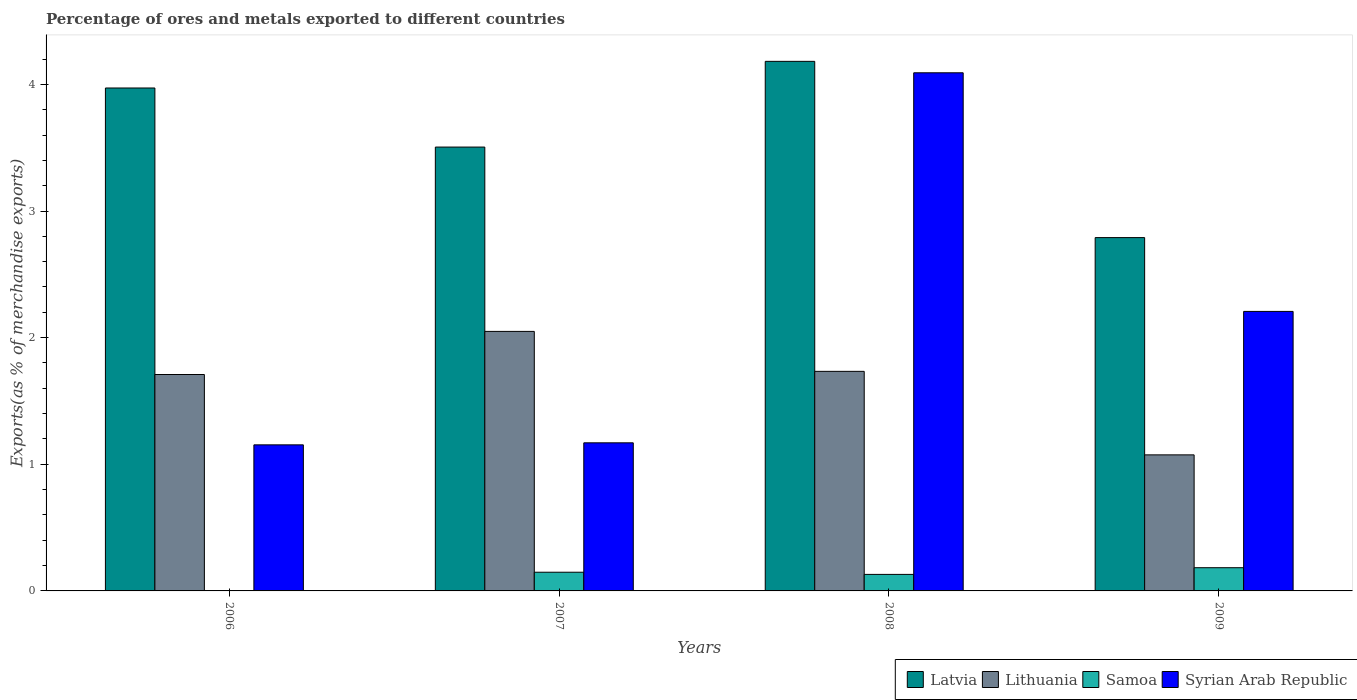How many groups of bars are there?
Your response must be concise. 4. Are the number of bars on each tick of the X-axis equal?
Your response must be concise. Yes. How many bars are there on the 1st tick from the right?
Your answer should be compact. 4. What is the label of the 4th group of bars from the left?
Provide a succinct answer. 2009. What is the percentage of exports to different countries in Samoa in 2009?
Give a very brief answer. 0.18. Across all years, what is the maximum percentage of exports to different countries in Latvia?
Provide a short and direct response. 4.18. Across all years, what is the minimum percentage of exports to different countries in Lithuania?
Provide a short and direct response. 1.07. In which year was the percentage of exports to different countries in Samoa maximum?
Keep it short and to the point. 2009. In which year was the percentage of exports to different countries in Latvia minimum?
Provide a succinct answer. 2009. What is the total percentage of exports to different countries in Syrian Arab Republic in the graph?
Provide a short and direct response. 8.62. What is the difference between the percentage of exports to different countries in Samoa in 2008 and that in 2009?
Provide a short and direct response. -0.05. What is the difference between the percentage of exports to different countries in Latvia in 2007 and the percentage of exports to different countries in Syrian Arab Republic in 2009?
Offer a terse response. 1.3. What is the average percentage of exports to different countries in Lithuania per year?
Keep it short and to the point. 1.64. In the year 2006, what is the difference between the percentage of exports to different countries in Samoa and percentage of exports to different countries in Lithuania?
Your answer should be very brief. -1.71. In how many years, is the percentage of exports to different countries in Samoa greater than 3.4 %?
Offer a terse response. 0. What is the ratio of the percentage of exports to different countries in Lithuania in 2006 to that in 2009?
Your answer should be compact. 1.59. Is the percentage of exports to different countries in Syrian Arab Republic in 2007 less than that in 2008?
Ensure brevity in your answer.  Yes. What is the difference between the highest and the second highest percentage of exports to different countries in Syrian Arab Republic?
Keep it short and to the point. 1.88. What is the difference between the highest and the lowest percentage of exports to different countries in Latvia?
Keep it short and to the point. 1.39. In how many years, is the percentage of exports to different countries in Syrian Arab Republic greater than the average percentage of exports to different countries in Syrian Arab Republic taken over all years?
Offer a very short reply. 2. Is the sum of the percentage of exports to different countries in Samoa in 2007 and 2009 greater than the maximum percentage of exports to different countries in Syrian Arab Republic across all years?
Provide a succinct answer. No. What does the 3rd bar from the left in 2007 represents?
Keep it short and to the point. Samoa. What does the 4th bar from the right in 2007 represents?
Offer a very short reply. Latvia. Are all the bars in the graph horizontal?
Keep it short and to the point. No. How many years are there in the graph?
Make the answer very short. 4. Are the values on the major ticks of Y-axis written in scientific E-notation?
Provide a succinct answer. No. Does the graph contain any zero values?
Give a very brief answer. No. What is the title of the graph?
Make the answer very short. Percentage of ores and metals exported to different countries. Does "Barbados" appear as one of the legend labels in the graph?
Your response must be concise. No. What is the label or title of the X-axis?
Give a very brief answer. Years. What is the label or title of the Y-axis?
Ensure brevity in your answer.  Exports(as % of merchandise exports). What is the Exports(as % of merchandise exports) of Latvia in 2006?
Ensure brevity in your answer.  3.97. What is the Exports(as % of merchandise exports) in Lithuania in 2006?
Offer a very short reply. 1.71. What is the Exports(as % of merchandise exports) in Samoa in 2006?
Keep it short and to the point. 0. What is the Exports(as % of merchandise exports) of Syrian Arab Republic in 2006?
Your response must be concise. 1.15. What is the Exports(as % of merchandise exports) in Latvia in 2007?
Give a very brief answer. 3.5. What is the Exports(as % of merchandise exports) of Lithuania in 2007?
Your response must be concise. 2.05. What is the Exports(as % of merchandise exports) of Samoa in 2007?
Make the answer very short. 0.15. What is the Exports(as % of merchandise exports) of Syrian Arab Republic in 2007?
Offer a terse response. 1.17. What is the Exports(as % of merchandise exports) in Latvia in 2008?
Offer a terse response. 4.18. What is the Exports(as % of merchandise exports) in Lithuania in 2008?
Ensure brevity in your answer.  1.73. What is the Exports(as % of merchandise exports) in Samoa in 2008?
Provide a succinct answer. 0.13. What is the Exports(as % of merchandise exports) in Syrian Arab Republic in 2008?
Offer a terse response. 4.09. What is the Exports(as % of merchandise exports) of Latvia in 2009?
Offer a very short reply. 2.79. What is the Exports(as % of merchandise exports) in Lithuania in 2009?
Provide a succinct answer. 1.07. What is the Exports(as % of merchandise exports) in Samoa in 2009?
Your answer should be compact. 0.18. What is the Exports(as % of merchandise exports) of Syrian Arab Republic in 2009?
Provide a succinct answer. 2.21. Across all years, what is the maximum Exports(as % of merchandise exports) in Latvia?
Provide a short and direct response. 4.18. Across all years, what is the maximum Exports(as % of merchandise exports) in Lithuania?
Offer a terse response. 2.05. Across all years, what is the maximum Exports(as % of merchandise exports) of Samoa?
Ensure brevity in your answer.  0.18. Across all years, what is the maximum Exports(as % of merchandise exports) of Syrian Arab Republic?
Give a very brief answer. 4.09. Across all years, what is the minimum Exports(as % of merchandise exports) of Latvia?
Give a very brief answer. 2.79. Across all years, what is the minimum Exports(as % of merchandise exports) in Lithuania?
Your response must be concise. 1.07. Across all years, what is the minimum Exports(as % of merchandise exports) in Samoa?
Offer a very short reply. 0. Across all years, what is the minimum Exports(as % of merchandise exports) in Syrian Arab Republic?
Make the answer very short. 1.15. What is the total Exports(as % of merchandise exports) of Latvia in the graph?
Provide a short and direct response. 14.45. What is the total Exports(as % of merchandise exports) of Lithuania in the graph?
Make the answer very short. 6.57. What is the total Exports(as % of merchandise exports) of Samoa in the graph?
Your answer should be very brief. 0.46. What is the total Exports(as % of merchandise exports) of Syrian Arab Republic in the graph?
Provide a succinct answer. 8.62. What is the difference between the Exports(as % of merchandise exports) of Latvia in 2006 and that in 2007?
Your answer should be very brief. 0.47. What is the difference between the Exports(as % of merchandise exports) in Lithuania in 2006 and that in 2007?
Offer a terse response. -0.34. What is the difference between the Exports(as % of merchandise exports) of Samoa in 2006 and that in 2007?
Keep it short and to the point. -0.15. What is the difference between the Exports(as % of merchandise exports) of Syrian Arab Republic in 2006 and that in 2007?
Keep it short and to the point. -0.02. What is the difference between the Exports(as % of merchandise exports) in Latvia in 2006 and that in 2008?
Provide a succinct answer. -0.21. What is the difference between the Exports(as % of merchandise exports) of Lithuania in 2006 and that in 2008?
Make the answer very short. -0.02. What is the difference between the Exports(as % of merchandise exports) in Samoa in 2006 and that in 2008?
Provide a short and direct response. -0.13. What is the difference between the Exports(as % of merchandise exports) of Syrian Arab Republic in 2006 and that in 2008?
Give a very brief answer. -2.94. What is the difference between the Exports(as % of merchandise exports) of Latvia in 2006 and that in 2009?
Your answer should be compact. 1.18. What is the difference between the Exports(as % of merchandise exports) of Lithuania in 2006 and that in 2009?
Provide a short and direct response. 0.63. What is the difference between the Exports(as % of merchandise exports) in Samoa in 2006 and that in 2009?
Make the answer very short. -0.18. What is the difference between the Exports(as % of merchandise exports) in Syrian Arab Republic in 2006 and that in 2009?
Ensure brevity in your answer.  -1.05. What is the difference between the Exports(as % of merchandise exports) in Latvia in 2007 and that in 2008?
Your answer should be very brief. -0.68. What is the difference between the Exports(as % of merchandise exports) in Lithuania in 2007 and that in 2008?
Give a very brief answer. 0.32. What is the difference between the Exports(as % of merchandise exports) in Samoa in 2007 and that in 2008?
Keep it short and to the point. 0.02. What is the difference between the Exports(as % of merchandise exports) of Syrian Arab Republic in 2007 and that in 2008?
Your response must be concise. -2.92. What is the difference between the Exports(as % of merchandise exports) of Latvia in 2007 and that in 2009?
Make the answer very short. 0.71. What is the difference between the Exports(as % of merchandise exports) of Lithuania in 2007 and that in 2009?
Offer a very short reply. 0.97. What is the difference between the Exports(as % of merchandise exports) of Samoa in 2007 and that in 2009?
Keep it short and to the point. -0.04. What is the difference between the Exports(as % of merchandise exports) of Syrian Arab Republic in 2007 and that in 2009?
Give a very brief answer. -1.04. What is the difference between the Exports(as % of merchandise exports) of Latvia in 2008 and that in 2009?
Your answer should be very brief. 1.39. What is the difference between the Exports(as % of merchandise exports) of Lithuania in 2008 and that in 2009?
Your response must be concise. 0.66. What is the difference between the Exports(as % of merchandise exports) of Samoa in 2008 and that in 2009?
Ensure brevity in your answer.  -0.05. What is the difference between the Exports(as % of merchandise exports) of Syrian Arab Republic in 2008 and that in 2009?
Ensure brevity in your answer.  1.88. What is the difference between the Exports(as % of merchandise exports) in Latvia in 2006 and the Exports(as % of merchandise exports) in Lithuania in 2007?
Your response must be concise. 1.92. What is the difference between the Exports(as % of merchandise exports) in Latvia in 2006 and the Exports(as % of merchandise exports) in Samoa in 2007?
Keep it short and to the point. 3.82. What is the difference between the Exports(as % of merchandise exports) of Latvia in 2006 and the Exports(as % of merchandise exports) of Syrian Arab Republic in 2007?
Provide a short and direct response. 2.8. What is the difference between the Exports(as % of merchandise exports) in Lithuania in 2006 and the Exports(as % of merchandise exports) in Samoa in 2007?
Make the answer very short. 1.56. What is the difference between the Exports(as % of merchandise exports) of Lithuania in 2006 and the Exports(as % of merchandise exports) of Syrian Arab Republic in 2007?
Make the answer very short. 0.54. What is the difference between the Exports(as % of merchandise exports) in Samoa in 2006 and the Exports(as % of merchandise exports) in Syrian Arab Republic in 2007?
Offer a terse response. -1.17. What is the difference between the Exports(as % of merchandise exports) of Latvia in 2006 and the Exports(as % of merchandise exports) of Lithuania in 2008?
Offer a terse response. 2.24. What is the difference between the Exports(as % of merchandise exports) in Latvia in 2006 and the Exports(as % of merchandise exports) in Samoa in 2008?
Keep it short and to the point. 3.84. What is the difference between the Exports(as % of merchandise exports) of Latvia in 2006 and the Exports(as % of merchandise exports) of Syrian Arab Republic in 2008?
Offer a very short reply. -0.12. What is the difference between the Exports(as % of merchandise exports) in Lithuania in 2006 and the Exports(as % of merchandise exports) in Samoa in 2008?
Your answer should be compact. 1.58. What is the difference between the Exports(as % of merchandise exports) in Lithuania in 2006 and the Exports(as % of merchandise exports) in Syrian Arab Republic in 2008?
Provide a succinct answer. -2.38. What is the difference between the Exports(as % of merchandise exports) in Samoa in 2006 and the Exports(as % of merchandise exports) in Syrian Arab Republic in 2008?
Provide a succinct answer. -4.09. What is the difference between the Exports(as % of merchandise exports) in Latvia in 2006 and the Exports(as % of merchandise exports) in Lithuania in 2009?
Your answer should be very brief. 2.9. What is the difference between the Exports(as % of merchandise exports) in Latvia in 2006 and the Exports(as % of merchandise exports) in Samoa in 2009?
Your answer should be compact. 3.79. What is the difference between the Exports(as % of merchandise exports) in Latvia in 2006 and the Exports(as % of merchandise exports) in Syrian Arab Republic in 2009?
Your response must be concise. 1.76. What is the difference between the Exports(as % of merchandise exports) in Lithuania in 2006 and the Exports(as % of merchandise exports) in Samoa in 2009?
Make the answer very short. 1.53. What is the difference between the Exports(as % of merchandise exports) in Lithuania in 2006 and the Exports(as % of merchandise exports) in Syrian Arab Republic in 2009?
Offer a terse response. -0.5. What is the difference between the Exports(as % of merchandise exports) in Samoa in 2006 and the Exports(as % of merchandise exports) in Syrian Arab Republic in 2009?
Make the answer very short. -2.21. What is the difference between the Exports(as % of merchandise exports) in Latvia in 2007 and the Exports(as % of merchandise exports) in Lithuania in 2008?
Make the answer very short. 1.77. What is the difference between the Exports(as % of merchandise exports) of Latvia in 2007 and the Exports(as % of merchandise exports) of Samoa in 2008?
Ensure brevity in your answer.  3.37. What is the difference between the Exports(as % of merchandise exports) of Latvia in 2007 and the Exports(as % of merchandise exports) of Syrian Arab Republic in 2008?
Offer a terse response. -0.59. What is the difference between the Exports(as % of merchandise exports) of Lithuania in 2007 and the Exports(as % of merchandise exports) of Samoa in 2008?
Offer a very short reply. 1.92. What is the difference between the Exports(as % of merchandise exports) in Lithuania in 2007 and the Exports(as % of merchandise exports) in Syrian Arab Republic in 2008?
Ensure brevity in your answer.  -2.04. What is the difference between the Exports(as % of merchandise exports) of Samoa in 2007 and the Exports(as % of merchandise exports) of Syrian Arab Republic in 2008?
Provide a succinct answer. -3.94. What is the difference between the Exports(as % of merchandise exports) of Latvia in 2007 and the Exports(as % of merchandise exports) of Lithuania in 2009?
Keep it short and to the point. 2.43. What is the difference between the Exports(as % of merchandise exports) in Latvia in 2007 and the Exports(as % of merchandise exports) in Samoa in 2009?
Your answer should be compact. 3.32. What is the difference between the Exports(as % of merchandise exports) of Latvia in 2007 and the Exports(as % of merchandise exports) of Syrian Arab Republic in 2009?
Provide a succinct answer. 1.3. What is the difference between the Exports(as % of merchandise exports) in Lithuania in 2007 and the Exports(as % of merchandise exports) in Samoa in 2009?
Give a very brief answer. 1.87. What is the difference between the Exports(as % of merchandise exports) of Lithuania in 2007 and the Exports(as % of merchandise exports) of Syrian Arab Republic in 2009?
Give a very brief answer. -0.16. What is the difference between the Exports(as % of merchandise exports) in Samoa in 2007 and the Exports(as % of merchandise exports) in Syrian Arab Republic in 2009?
Make the answer very short. -2.06. What is the difference between the Exports(as % of merchandise exports) in Latvia in 2008 and the Exports(as % of merchandise exports) in Lithuania in 2009?
Keep it short and to the point. 3.11. What is the difference between the Exports(as % of merchandise exports) of Latvia in 2008 and the Exports(as % of merchandise exports) of Samoa in 2009?
Make the answer very short. 4. What is the difference between the Exports(as % of merchandise exports) in Latvia in 2008 and the Exports(as % of merchandise exports) in Syrian Arab Republic in 2009?
Offer a terse response. 1.97. What is the difference between the Exports(as % of merchandise exports) of Lithuania in 2008 and the Exports(as % of merchandise exports) of Samoa in 2009?
Offer a terse response. 1.55. What is the difference between the Exports(as % of merchandise exports) in Lithuania in 2008 and the Exports(as % of merchandise exports) in Syrian Arab Republic in 2009?
Offer a very short reply. -0.47. What is the difference between the Exports(as % of merchandise exports) of Samoa in 2008 and the Exports(as % of merchandise exports) of Syrian Arab Republic in 2009?
Ensure brevity in your answer.  -2.08. What is the average Exports(as % of merchandise exports) in Latvia per year?
Offer a terse response. 3.61. What is the average Exports(as % of merchandise exports) of Lithuania per year?
Provide a succinct answer. 1.64. What is the average Exports(as % of merchandise exports) of Samoa per year?
Your answer should be compact. 0.12. What is the average Exports(as % of merchandise exports) of Syrian Arab Republic per year?
Offer a terse response. 2.16. In the year 2006, what is the difference between the Exports(as % of merchandise exports) of Latvia and Exports(as % of merchandise exports) of Lithuania?
Offer a terse response. 2.26. In the year 2006, what is the difference between the Exports(as % of merchandise exports) of Latvia and Exports(as % of merchandise exports) of Samoa?
Offer a terse response. 3.97. In the year 2006, what is the difference between the Exports(as % of merchandise exports) of Latvia and Exports(as % of merchandise exports) of Syrian Arab Republic?
Give a very brief answer. 2.82. In the year 2006, what is the difference between the Exports(as % of merchandise exports) of Lithuania and Exports(as % of merchandise exports) of Samoa?
Keep it short and to the point. 1.71. In the year 2006, what is the difference between the Exports(as % of merchandise exports) of Lithuania and Exports(as % of merchandise exports) of Syrian Arab Republic?
Give a very brief answer. 0.56. In the year 2006, what is the difference between the Exports(as % of merchandise exports) of Samoa and Exports(as % of merchandise exports) of Syrian Arab Republic?
Make the answer very short. -1.15. In the year 2007, what is the difference between the Exports(as % of merchandise exports) in Latvia and Exports(as % of merchandise exports) in Lithuania?
Your response must be concise. 1.46. In the year 2007, what is the difference between the Exports(as % of merchandise exports) of Latvia and Exports(as % of merchandise exports) of Samoa?
Provide a succinct answer. 3.36. In the year 2007, what is the difference between the Exports(as % of merchandise exports) in Latvia and Exports(as % of merchandise exports) in Syrian Arab Republic?
Ensure brevity in your answer.  2.34. In the year 2007, what is the difference between the Exports(as % of merchandise exports) of Lithuania and Exports(as % of merchandise exports) of Samoa?
Offer a very short reply. 1.9. In the year 2007, what is the difference between the Exports(as % of merchandise exports) of Lithuania and Exports(as % of merchandise exports) of Syrian Arab Republic?
Provide a succinct answer. 0.88. In the year 2007, what is the difference between the Exports(as % of merchandise exports) in Samoa and Exports(as % of merchandise exports) in Syrian Arab Republic?
Make the answer very short. -1.02. In the year 2008, what is the difference between the Exports(as % of merchandise exports) of Latvia and Exports(as % of merchandise exports) of Lithuania?
Your response must be concise. 2.45. In the year 2008, what is the difference between the Exports(as % of merchandise exports) of Latvia and Exports(as % of merchandise exports) of Samoa?
Provide a short and direct response. 4.05. In the year 2008, what is the difference between the Exports(as % of merchandise exports) in Latvia and Exports(as % of merchandise exports) in Syrian Arab Republic?
Your answer should be compact. 0.09. In the year 2008, what is the difference between the Exports(as % of merchandise exports) of Lithuania and Exports(as % of merchandise exports) of Samoa?
Give a very brief answer. 1.6. In the year 2008, what is the difference between the Exports(as % of merchandise exports) in Lithuania and Exports(as % of merchandise exports) in Syrian Arab Republic?
Provide a succinct answer. -2.36. In the year 2008, what is the difference between the Exports(as % of merchandise exports) of Samoa and Exports(as % of merchandise exports) of Syrian Arab Republic?
Your response must be concise. -3.96. In the year 2009, what is the difference between the Exports(as % of merchandise exports) in Latvia and Exports(as % of merchandise exports) in Lithuania?
Ensure brevity in your answer.  1.72. In the year 2009, what is the difference between the Exports(as % of merchandise exports) of Latvia and Exports(as % of merchandise exports) of Samoa?
Keep it short and to the point. 2.61. In the year 2009, what is the difference between the Exports(as % of merchandise exports) of Latvia and Exports(as % of merchandise exports) of Syrian Arab Republic?
Offer a terse response. 0.58. In the year 2009, what is the difference between the Exports(as % of merchandise exports) of Lithuania and Exports(as % of merchandise exports) of Samoa?
Your response must be concise. 0.89. In the year 2009, what is the difference between the Exports(as % of merchandise exports) of Lithuania and Exports(as % of merchandise exports) of Syrian Arab Republic?
Offer a terse response. -1.13. In the year 2009, what is the difference between the Exports(as % of merchandise exports) of Samoa and Exports(as % of merchandise exports) of Syrian Arab Republic?
Your answer should be very brief. -2.02. What is the ratio of the Exports(as % of merchandise exports) of Latvia in 2006 to that in 2007?
Provide a short and direct response. 1.13. What is the ratio of the Exports(as % of merchandise exports) of Lithuania in 2006 to that in 2007?
Give a very brief answer. 0.83. What is the ratio of the Exports(as % of merchandise exports) of Samoa in 2006 to that in 2007?
Your answer should be compact. 0.01. What is the ratio of the Exports(as % of merchandise exports) of Syrian Arab Republic in 2006 to that in 2007?
Provide a succinct answer. 0.99. What is the ratio of the Exports(as % of merchandise exports) in Latvia in 2006 to that in 2008?
Offer a terse response. 0.95. What is the ratio of the Exports(as % of merchandise exports) in Lithuania in 2006 to that in 2008?
Provide a succinct answer. 0.99. What is the ratio of the Exports(as % of merchandise exports) in Samoa in 2006 to that in 2008?
Your answer should be very brief. 0.02. What is the ratio of the Exports(as % of merchandise exports) in Syrian Arab Republic in 2006 to that in 2008?
Offer a very short reply. 0.28. What is the ratio of the Exports(as % of merchandise exports) of Latvia in 2006 to that in 2009?
Ensure brevity in your answer.  1.42. What is the ratio of the Exports(as % of merchandise exports) in Lithuania in 2006 to that in 2009?
Keep it short and to the point. 1.59. What is the ratio of the Exports(as % of merchandise exports) of Samoa in 2006 to that in 2009?
Offer a very short reply. 0.01. What is the ratio of the Exports(as % of merchandise exports) of Syrian Arab Republic in 2006 to that in 2009?
Make the answer very short. 0.52. What is the ratio of the Exports(as % of merchandise exports) of Latvia in 2007 to that in 2008?
Keep it short and to the point. 0.84. What is the ratio of the Exports(as % of merchandise exports) of Lithuania in 2007 to that in 2008?
Keep it short and to the point. 1.18. What is the ratio of the Exports(as % of merchandise exports) in Samoa in 2007 to that in 2008?
Your answer should be very brief. 1.13. What is the ratio of the Exports(as % of merchandise exports) of Syrian Arab Republic in 2007 to that in 2008?
Ensure brevity in your answer.  0.29. What is the ratio of the Exports(as % of merchandise exports) in Latvia in 2007 to that in 2009?
Provide a short and direct response. 1.26. What is the ratio of the Exports(as % of merchandise exports) in Lithuania in 2007 to that in 2009?
Your answer should be compact. 1.91. What is the ratio of the Exports(as % of merchandise exports) in Samoa in 2007 to that in 2009?
Your answer should be compact. 0.81. What is the ratio of the Exports(as % of merchandise exports) of Syrian Arab Republic in 2007 to that in 2009?
Give a very brief answer. 0.53. What is the ratio of the Exports(as % of merchandise exports) of Latvia in 2008 to that in 2009?
Ensure brevity in your answer.  1.5. What is the ratio of the Exports(as % of merchandise exports) in Lithuania in 2008 to that in 2009?
Offer a very short reply. 1.61. What is the ratio of the Exports(as % of merchandise exports) of Samoa in 2008 to that in 2009?
Your response must be concise. 0.71. What is the ratio of the Exports(as % of merchandise exports) in Syrian Arab Republic in 2008 to that in 2009?
Provide a succinct answer. 1.85. What is the difference between the highest and the second highest Exports(as % of merchandise exports) in Latvia?
Offer a terse response. 0.21. What is the difference between the highest and the second highest Exports(as % of merchandise exports) of Lithuania?
Make the answer very short. 0.32. What is the difference between the highest and the second highest Exports(as % of merchandise exports) of Samoa?
Give a very brief answer. 0.04. What is the difference between the highest and the second highest Exports(as % of merchandise exports) of Syrian Arab Republic?
Offer a terse response. 1.88. What is the difference between the highest and the lowest Exports(as % of merchandise exports) in Latvia?
Your answer should be compact. 1.39. What is the difference between the highest and the lowest Exports(as % of merchandise exports) in Lithuania?
Keep it short and to the point. 0.97. What is the difference between the highest and the lowest Exports(as % of merchandise exports) in Samoa?
Make the answer very short. 0.18. What is the difference between the highest and the lowest Exports(as % of merchandise exports) in Syrian Arab Republic?
Offer a terse response. 2.94. 